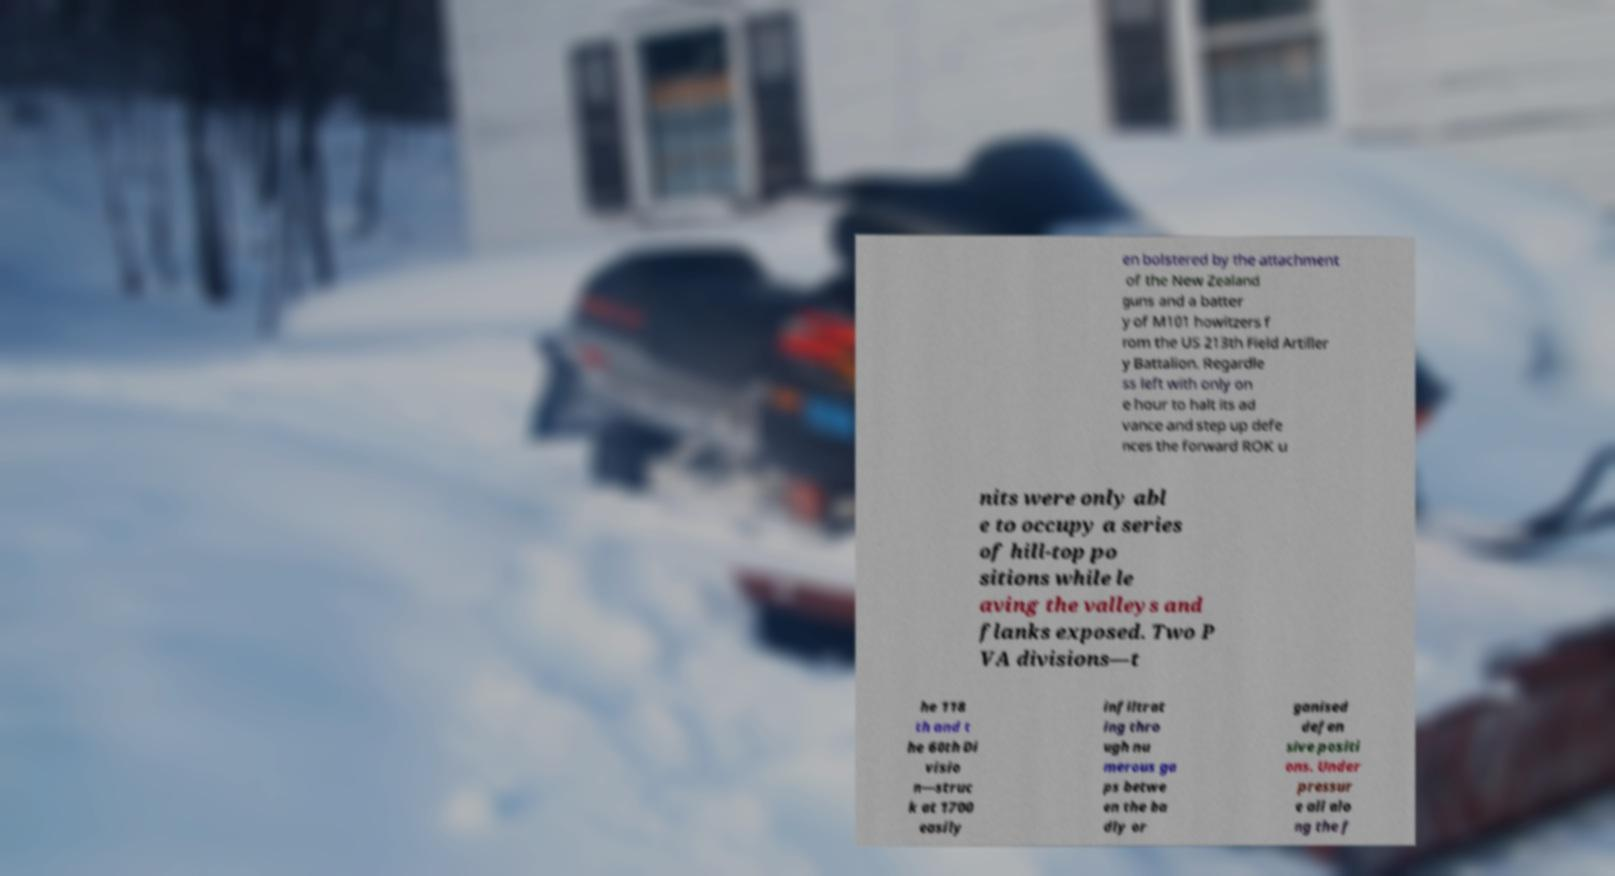Please identify and transcribe the text found in this image. en bolstered by the attachment of the New Zealand guns and a batter y of M101 howitzers f rom the US 213th Field Artiller y Battalion. Regardle ss left with only on e hour to halt its ad vance and step up defe nces the forward ROK u nits were only abl e to occupy a series of hill-top po sitions while le aving the valleys and flanks exposed. Two P VA divisions—t he 118 th and t he 60th Di visio n—struc k at 1700 easily infiltrat ing thro ugh nu merous ga ps betwe en the ba dly or ganised defen sive positi ons. Under pressur e all alo ng the f 